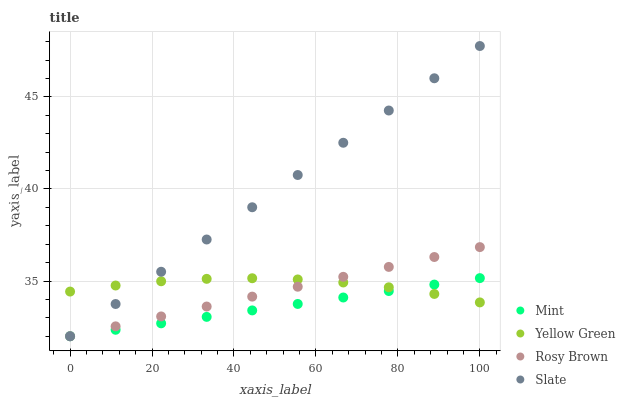Does Mint have the minimum area under the curve?
Answer yes or no. Yes. Does Slate have the maximum area under the curve?
Answer yes or no. Yes. Does Rosy Brown have the minimum area under the curve?
Answer yes or no. No. Does Rosy Brown have the maximum area under the curve?
Answer yes or no. No. Is Mint the smoothest?
Answer yes or no. Yes. Is Yellow Green the roughest?
Answer yes or no. Yes. Is Rosy Brown the smoothest?
Answer yes or no. No. Is Rosy Brown the roughest?
Answer yes or no. No. Does Slate have the lowest value?
Answer yes or no. Yes. Does Yellow Green have the lowest value?
Answer yes or no. No. Does Slate have the highest value?
Answer yes or no. Yes. Does Rosy Brown have the highest value?
Answer yes or no. No. Does Yellow Green intersect Mint?
Answer yes or no. Yes. Is Yellow Green less than Mint?
Answer yes or no. No. Is Yellow Green greater than Mint?
Answer yes or no. No. 